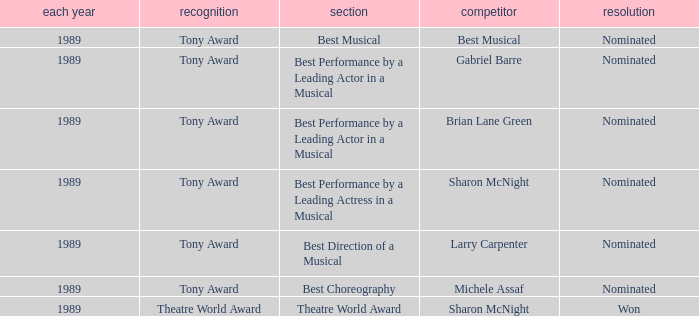What year was michele assaf nominated 1989.0. 